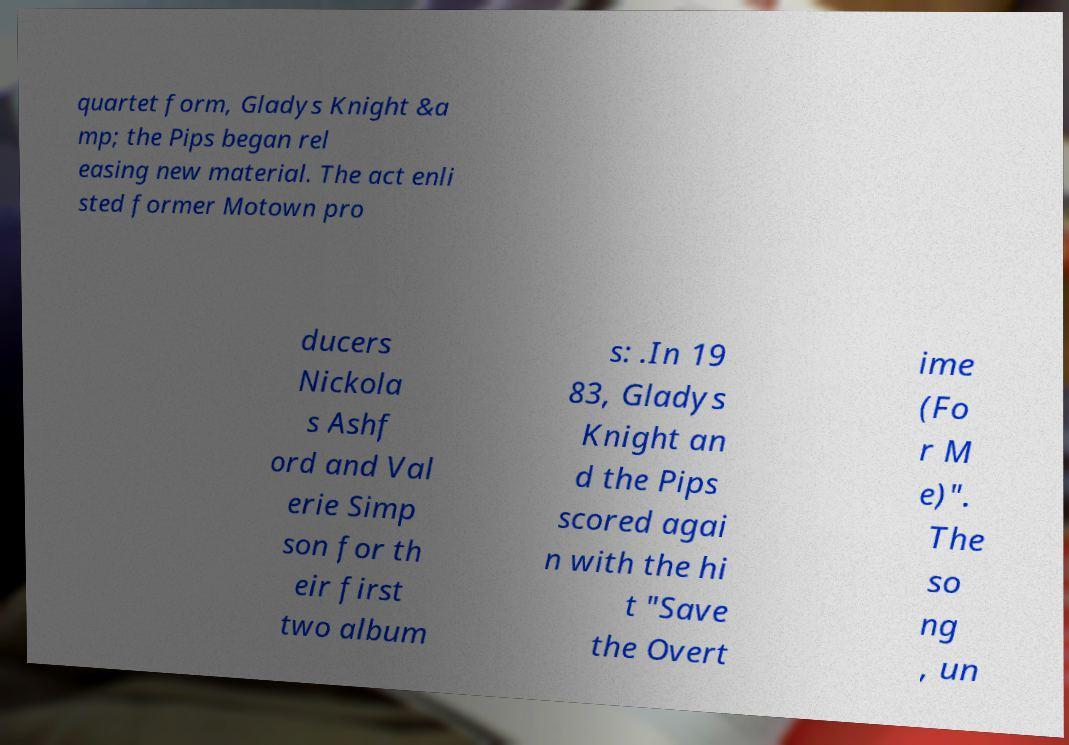Please read and relay the text visible in this image. What does it say? quartet form, Gladys Knight &a mp; the Pips began rel easing new material. The act enli sted former Motown pro ducers Nickola s Ashf ord and Val erie Simp son for th eir first two album s: .In 19 83, Gladys Knight an d the Pips scored agai n with the hi t "Save the Overt ime (Fo r M e)". The so ng , un 